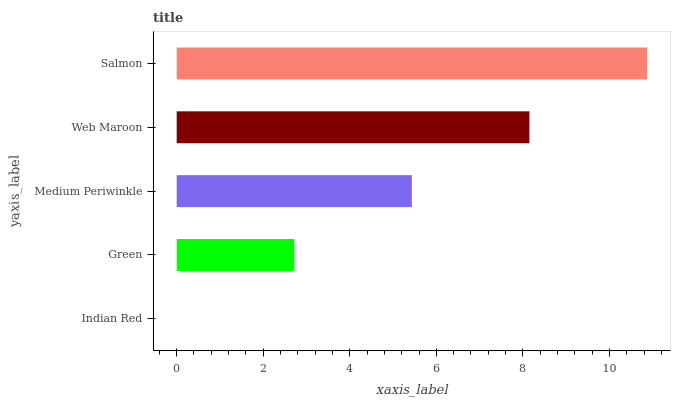Is Indian Red the minimum?
Answer yes or no. Yes. Is Salmon the maximum?
Answer yes or no. Yes. Is Green the minimum?
Answer yes or no. No. Is Green the maximum?
Answer yes or no. No. Is Green greater than Indian Red?
Answer yes or no. Yes. Is Indian Red less than Green?
Answer yes or no. Yes. Is Indian Red greater than Green?
Answer yes or no. No. Is Green less than Indian Red?
Answer yes or no. No. Is Medium Periwinkle the high median?
Answer yes or no. Yes. Is Medium Periwinkle the low median?
Answer yes or no. Yes. Is Web Maroon the high median?
Answer yes or no. No. Is Web Maroon the low median?
Answer yes or no. No. 